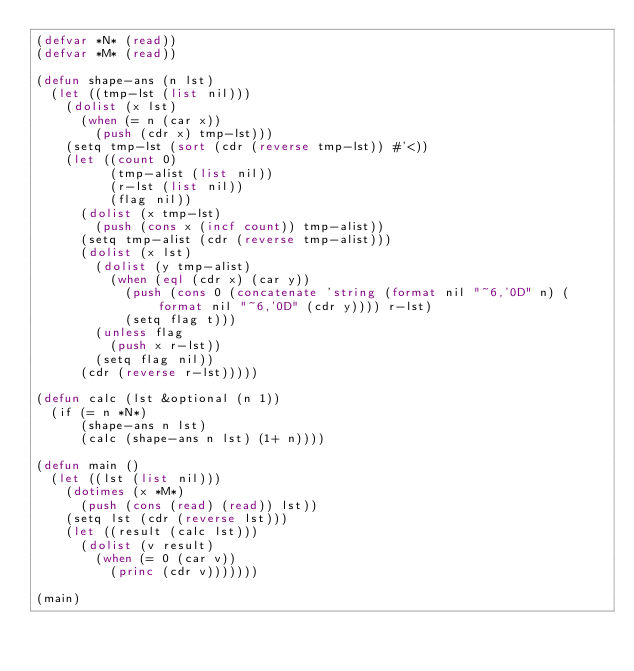Convert code to text. <code><loc_0><loc_0><loc_500><loc_500><_Lisp_>(defvar *N* (read))
(defvar *M* (read))

(defun shape-ans (n lst)
  (let ((tmp-lst (list nil)))
    (dolist (x lst)
      (when (= n (car x))
        (push (cdr x) tmp-lst)))
    (setq tmp-lst (sort (cdr (reverse tmp-lst)) #'<))
    (let ((count 0)
          (tmp-alist (list nil))
          (r-lst (list nil))
          (flag nil))
      (dolist (x tmp-lst)
        (push (cons x (incf count)) tmp-alist))
      (setq tmp-alist (cdr (reverse tmp-alist)))
      (dolist (x lst)
        (dolist (y tmp-alist)
          (when (eql (cdr x) (car y))
            (push (cons 0 (concatenate 'string (format nil "~6,'0D" n) (format nil "~6,'0D" (cdr y)))) r-lst)
            (setq flag t)))
        (unless flag
          (push x r-lst))
        (setq flag nil))
      (cdr (reverse r-lst)))))

(defun calc (lst &optional (n 1))
  (if (= n *N*)
      (shape-ans n lst)
      (calc (shape-ans n lst) (1+ n))))

(defun main ()
  (let ((lst (list nil)))
    (dotimes (x *M*)
      (push (cons (read) (read)) lst))
    (setq lst (cdr (reverse lst)))
    (let ((result (calc lst)))
      (dolist (v result)
        (when (= 0 (car v))
          (princ (cdr v)))))))

(main)</code> 